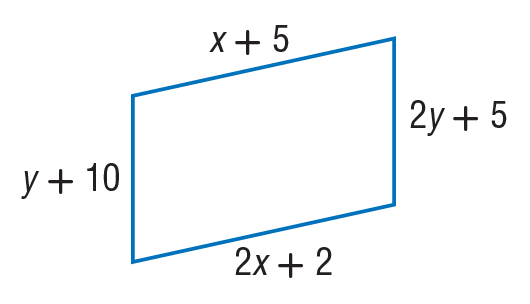Answer the mathemtical geometry problem and directly provide the correct option letter.
Question: Find x so that the quadrilateral is a parallelogram.
Choices: A: 3 B: 5 C: 7 D: 8 A 